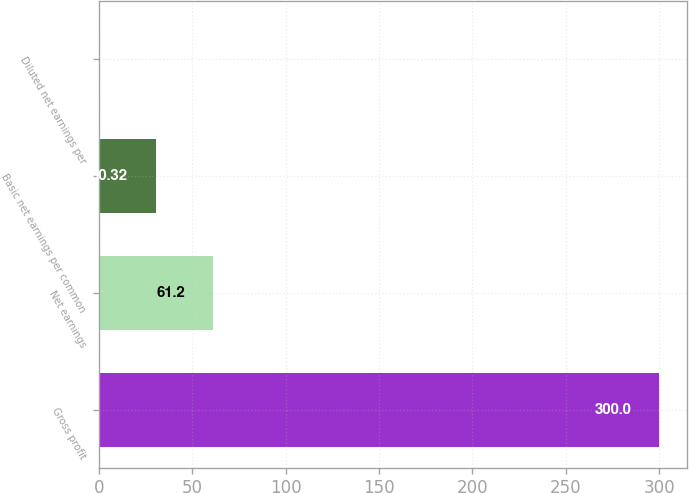Convert chart to OTSL. <chart><loc_0><loc_0><loc_500><loc_500><bar_chart><fcel>Gross profit<fcel>Net earnings<fcel>Basic net earnings per common<fcel>Diluted net earnings per<nl><fcel>300<fcel>61.2<fcel>30.32<fcel>0.35<nl></chart> 